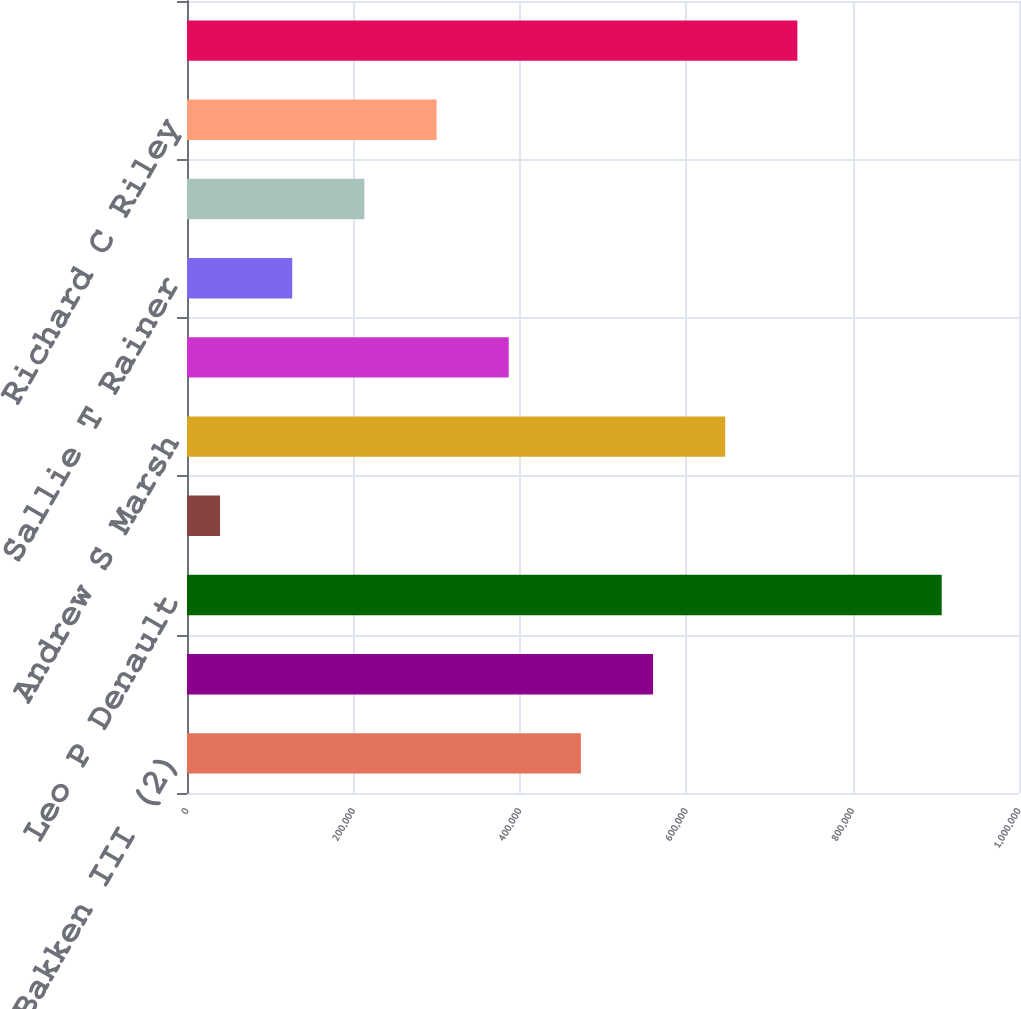Convert chart. <chart><loc_0><loc_0><loc_500><loc_500><bar_chart><fcel>A Christopher Bakken III (2)<fcel>Marcus V Brown<fcel>Leo P Denault<fcel>Haley R Fisackerly<fcel>Andrew S Marsh<fcel>Phillip R May Jr<fcel>Sallie T Rainer<fcel>Charles L Rice Jr<fcel>Richard C Riley<fcel>Roderick K West<nl><fcel>473416<fcel>560153<fcel>907105<fcel>39726<fcel>646891<fcel>386678<fcel>126464<fcel>213202<fcel>299940<fcel>733629<nl></chart> 